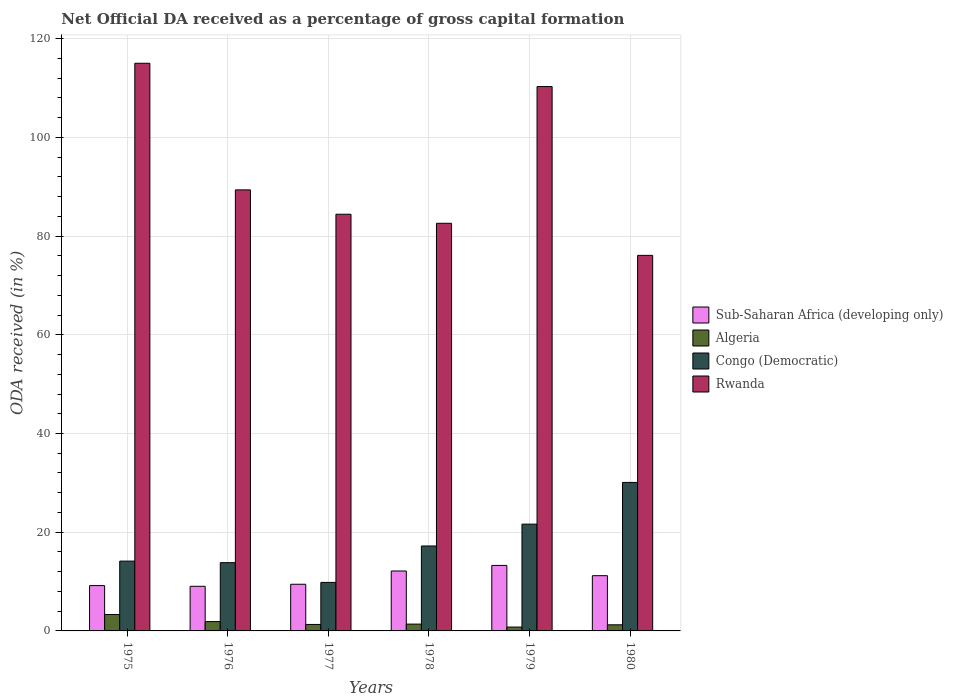How many different coloured bars are there?
Provide a succinct answer. 4. Are the number of bars on each tick of the X-axis equal?
Make the answer very short. Yes. How many bars are there on the 2nd tick from the left?
Provide a short and direct response. 4. What is the label of the 1st group of bars from the left?
Your answer should be very brief. 1975. What is the net ODA received in Rwanda in 1977?
Your answer should be compact. 84.43. Across all years, what is the maximum net ODA received in Congo (Democratic)?
Keep it short and to the point. 30.09. Across all years, what is the minimum net ODA received in Sub-Saharan Africa (developing only)?
Your response must be concise. 9.04. In which year was the net ODA received in Algeria maximum?
Your answer should be compact. 1975. What is the total net ODA received in Algeria in the graph?
Give a very brief answer. 9.94. What is the difference between the net ODA received in Rwanda in 1975 and that in 1978?
Give a very brief answer. 32.42. What is the difference between the net ODA received in Sub-Saharan Africa (developing only) in 1975 and the net ODA received in Algeria in 1979?
Make the answer very short. 8.4. What is the average net ODA received in Algeria per year?
Provide a succinct answer. 1.66. In the year 1980, what is the difference between the net ODA received in Algeria and net ODA received in Congo (Democratic)?
Make the answer very short. -28.85. What is the ratio of the net ODA received in Congo (Democratic) in 1975 to that in 1976?
Give a very brief answer. 1.02. Is the net ODA received in Sub-Saharan Africa (developing only) in 1976 less than that in 1979?
Your answer should be very brief. Yes. What is the difference between the highest and the second highest net ODA received in Algeria?
Offer a terse response. 1.44. What is the difference between the highest and the lowest net ODA received in Algeria?
Provide a succinct answer. 2.55. Is it the case that in every year, the sum of the net ODA received in Sub-Saharan Africa (developing only) and net ODA received in Rwanda is greater than the sum of net ODA received in Congo (Democratic) and net ODA received in Algeria?
Ensure brevity in your answer.  Yes. What does the 2nd bar from the left in 1977 represents?
Your response must be concise. Algeria. What does the 4th bar from the right in 1977 represents?
Your response must be concise. Sub-Saharan Africa (developing only). Is it the case that in every year, the sum of the net ODA received in Algeria and net ODA received in Rwanda is greater than the net ODA received in Congo (Democratic)?
Make the answer very short. Yes. How are the legend labels stacked?
Provide a short and direct response. Vertical. What is the title of the graph?
Offer a very short reply. Net Official DA received as a percentage of gross capital formation. What is the label or title of the X-axis?
Provide a short and direct response. Years. What is the label or title of the Y-axis?
Provide a short and direct response. ODA received (in %). What is the ODA received (in %) in Sub-Saharan Africa (developing only) in 1975?
Your answer should be compact. 9.18. What is the ODA received (in %) in Algeria in 1975?
Offer a terse response. 3.33. What is the ODA received (in %) of Congo (Democratic) in 1975?
Provide a succinct answer. 14.15. What is the ODA received (in %) in Rwanda in 1975?
Give a very brief answer. 115.02. What is the ODA received (in %) in Sub-Saharan Africa (developing only) in 1976?
Provide a short and direct response. 9.04. What is the ODA received (in %) in Algeria in 1976?
Make the answer very short. 1.89. What is the ODA received (in %) of Congo (Democratic) in 1976?
Provide a succinct answer. 13.83. What is the ODA received (in %) of Rwanda in 1976?
Make the answer very short. 89.36. What is the ODA received (in %) in Sub-Saharan Africa (developing only) in 1977?
Make the answer very short. 9.45. What is the ODA received (in %) in Algeria in 1977?
Give a very brief answer. 1.31. What is the ODA received (in %) in Congo (Democratic) in 1977?
Give a very brief answer. 9.83. What is the ODA received (in %) in Rwanda in 1977?
Your response must be concise. 84.43. What is the ODA received (in %) in Sub-Saharan Africa (developing only) in 1978?
Offer a very short reply. 12.14. What is the ODA received (in %) of Algeria in 1978?
Your answer should be compact. 1.38. What is the ODA received (in %) of Congo (Democratic) in 1978?
Provide a short and direct response. 17.21. What is the ODA received (in %) of Rwanda in 1978?
Your answer should be very brief. 82.6. What is the ODA received (in %) of Sub-Saharan Africa (developing only) in 1979?
Provide a short and direct response. 13.27. What is the ODA received (in %) in Algeria in 1979?
Ensure brevity in your answer.  0.78. What is the ODA received (in %) in Congo (Democratic) in 1979?
Offer a terse response. 21.64. What is the ODA received (in %) in Rwanda in 1979?
Offer a terse response. 110.3. What is the ODA received (in %) in Sub-Saharan Africa (developing only) in 1980?
Keep it short and to the point. 11.19. What is the ODA received (in %) of Algeria in 1980?
Give a very brief answer. 1.24. What is the ODA received (in %) in Congo (Democratic) in 1980?
Your response must be concise. 30.09. What is the ODA received (in %) of Rwanda in 1980?
Your answer should be compact. 76.09. Across all years, what is the maximum ODA received (in %) of Sub-Saharan Africa (developing only)?
Give a very brief answer. 13.27. Across all years, what is the maximum ODA received (in %) in Algeria?
Ensure brevity in your answer.  3.33. Across all years, what is the maximum ODA received (in %) of Congo (Democratic)?
Your answer should be very brief. 30.09. Across all years, what is the maximum ODA received (in %) of Rwanda?
Ensure brevity in your answer.  115.02. Across all years, what is the minimum ODA received (in %) in Sub-Saharan Africa (developing only)?
Keep it short and to the point. 9.04. Across all years, what is the minimum ODA received (in %) of Algeria?
Your answer should be very brief. 0.78. Across all years, what is the minimum ODA received (in %) of Congo (Democratic)?
Ensure brevity in your answer.  9.83. Across all years, what is the minimum ODA received (in %) in Rwanda?
Provide a succinct answer. 76.09. What is the total ODA received (in %) of Sub-Saharan Africa (developing only) in the graph?
Provide a short and direct response. 64.29. What is the total ODA received (in %) of Algeria in the graph?
Offer a very short reply. 9.94. What is the total ODA received (in %) of Congo (Democratic) in the graph?
Ensure brevity in your answer.  106.74. What is the total ODA received (in %) in Rwanda in the graph?
Keep it short and to the point. 557.81. What is the difference between the ODA received (in %) of Sub-Saharan Africa (developing only) in 1975 and that in 1976?
Provide a short and direct response. 0.14. What is the difference between the ODA received (in %) of Algeria in 1975 and that in 1976?
Keep it short and to the point. 1.44. What is the difference between the ODA received (in %) in Congo (Democratic) in 1975 and that in 1976?
Ensure brevity in your answer.  0.31. What is the difference between the ODA received (in %) of Rwanda in 1975 and that in 1976?
Offer a terse response. 25.66. What is the difference between the ODA received (in %) of Sub-Saharan Africa (developing only) in 1975 and that in 1977?
Your answer should be compact. -0.27. What is the difference between the ODA received (in %) of Algeria in 1975 and that in 1977?
Make the answer very short. 2.02. What is the difference between the ODA received (in %) in Congo (Democratic) in 1975 and that in 1977?
Make the answer very short. 4.32. What is the difference between the ODA received (in %) in Rwanda in 1975 and that in 1977?
Provide a succinct answer. 30.59. What is the difference between the ODA received (in %) in Sub-Saharan Africa (developing only) in 1975 and that in 1978?
Keep it short and to the point. -2.96. What is the difference between the ODA received (in %) in Algeria in 1975 and that in 1978?
Give a very brief answer. 1.95. What is the difference between the ODA received (in %) in Congo (Democratic) in 1975 and that in 1978?
Offer a very short reply. -3.06. What is the difference between the ODA received (in %) in Rwanda in 1975 and that in 1978?
Ensure brevity in your answer.  32.42. What is the difference between the ODA received (in %) in Sub-Saharan Africa (developing only) in 1975 and that in 1979?
Keep it short and to the point. -4.09. What is the difference between the ODA received (in %) of Algeria in 1975 and that in 1979?
Give a very brief answer. 2.55. What is the difference between the ODA received (in %) of Congo (Democratic) in 1975 and that in 1979?
Ensure brevity in your answer.  -7.49. What is the difference between the ODA received (in %) in Rwanda in 1975 and that in 1979?
Provide a short and direct response. 4.72. What is the difference between the ODA received (in %) of Sub-Saharan Africa (developing only) in 1975 and that in 1980?
Offer a terse response. -2.01. What is the difference between the ODA received (in %) in Algeria in 1975 and that in 1980?
Offer a terse response. 2.09. What is the difference between the ODA received (in %) in Congo (Democratic) in 1975 and that in 1980?
Offer a terse response. -15.94. What is the difference between the ODA received (in %) in Rwanda in 1975 and that in 1980?
Offer a very short reply. 38.93. What is the difference between the ODA received (in %) in Sub-Saharan Africa (developing only) in 1976 and that in 1977?
Your answer should be very brief. -0.41. What is the difference between the ODA received (in %) in Algeria in 1976 and that in 1977?
Give a very brief answer. 0.58. What is the difference between the ODA received (in %) of Congo (Democratic) in 1976 and that in 1977?
Offer a terse response. 4. What is the difference between the ODA received (in %) in Rwanda in 1976 and that in 1977?
Keep it short and to the point. 4.93. What is the difference between the ODA received (in %) of Sub-Saharan Africa (developing only) in 1976 and that in 1978?
Your answer should be compact. -3.1. What is the difference between the ODA received (in %) in Algeria in 1976 and that in 1978?
Your answer should be compact. 0.51. What is the difference between the ODA received (in %) of Congo (Democratic) in 1976 and that in 1978?
Offer a terse response. -3.38. What is the difference between the ODA received (in %) in Rwanda in 1976 and that in 1978?
Provide a succinct answer. 6.76. What is the difference between the ODA received (in %) of Sub-Saharan Africa (developing only) in 1976 and that in 1979?
Offer a very short reply. -4.23. What is the difference between the ODA received (in %) of Algeria in 1976 and that in 1979?
Give a very brief answer. 1.11. What is the difference between the ODA received (in %) in Congo (Democratic) in 1976 and that in 1979?
Your answer should be very brief. -7.81. What is the difference between the ODA received (in %) of Rwanda in 1976 and that in 1979?
Provide a succinct answer. -20.94. What is the difference between the ODA received (in %) of Sub-Saharan Africa (developing only) in 1976 and that in 1980?
Ensure brevity in your answer.  -2.15. What is the difference between the ODA received (in %) of Algeria in 1976 and that in 1980?
Ensure brevity in your answer.  0.65. What is the difference between the ODA received (in %) in Congo (Democratic) in 1976 and that in 1980?
Your response must be concise. -16.26. What is the difference between the ODA received (in %) in Rwanda in 1976 and that in 1980?
Make the answer very short. 13.27. What is the difference between the ODA received (in %) in Sub-Saharan Africa (developing only) in 1977 and that in 1978?
Offer a terse response. -2.69. What is the difference between the ODA received (in %) in Algeria in 1977 and that in 1978?
Provide a succinct answer. -0.07. What is the difference between the ODA received (in %) in Congo (Democratic) in 1977 and that in 1978?
Offer a very short reply. -7.38. What is the difference between the ODA received (in %) of Rwanda in 1977 and that in 1978?
Keep it short and to the point. 1.83. What is the difference between the ODA received (in %) of Sub-Saharan Africa (developing only) in 1977 and that in 1979?
Offer a terse response. -3.82. What is the difference between the ODA received (in %) in Algeria in 1977 and that in 1979?
Keep it short and to the point. 0.53. What is the difference between the ODA received (in %) of Congo (Democratic) in 1977 and that in 1979?
Offer a very short reply. -11.81. What is the difference between the ODA received (in %) of Rwanda in 1977 and that in 1979?
Offer a very short reply. -25.87. What is the difference between the ODA received (in %) in Sub-Saharan Africa (developing only) in 1977 and that in 1980?
Provide a succinct answer. -1.74. What is the difference between the ODA received (in %) of Algeria in 1977 and that in 1980?
Your response must be concise. 0.07. What is the difference between the ODA received (in %) in Congo (Democratic) in 1977 and that in 1980?
Provide a succinct answer. -20.26. What is the difference between the ODA received (in %) of Rwanda in 1977 and that in 1980?
Your answer should be very brief. 8.34. What is the difference between the ODA received (in %) in Sub-Saharan Africa (developing only) in 1978 and that in 1979?
Your answer should be compact. -1.13. What is the difference between the ODA received (in %) in Algeria in 1978 and that in 1979?
Provide a succinct answer. 0.6. What is the difference between the ODA received (in %) in Congo (Democratic) in 1978 and that in 1979?
Your response must be concise. -4.43. What is the difference between the ODA received (in %) of Rwanda in 1978 and that in 1979?
Your response must be concise. -27.7. What is the difference between the ODA received (in %) in Sub-Saharan Africa (developing only) in 1978 and that in 1980?
Offer a very short reply. 0.95. What is the difference between the ODA received (in %) in Algeria in 1978 and that in 1980?
Ensure brevity in your answer.  0.14. What is the difference between the ODA received (in %) of Congo (Democratic) in 1978 and that in 1980?
Offer a very short reply. -12.88. What is the difference between the ODA received (in %) in Rwanda in 1978 and that in 1980?
Your response must be concise. 6.51. What is the difference between the ODA received (in %) of Sub-Saharan Africa (developing only) in 1979 and that in 1980?
Keep it short and to the point. 2.08. What is the difference between the ODA received (in %) in Algeria in 1979 and that in 1980?
Give a very brief answer. -0.46. What is the difference between the ODA received (in %) in Congo (Democratic) in 1979 and that in 1980?
Ensure brevity in your answer.  -8.45. What is the difference between the ODA received (in %) of Rwanda in 1979 and that in 1980?
Your answer should be compact. 34.21. What is the difference between the ODA received (in %) of Sub-Saharan Africa (developing only) in 1975 and the ODA received (in %) of Algeria in 1976?
Provide a short and direct response. 7.29. What is the difference between the ODA received (in %) of Sub-Saharan Africa (developing only) in 1975 and the ODA received (in %) of Congo (Democratic) in 1976?
Your response must be concise. -4.65. What is the difference between the ODA received (in %) of Sub-Saharan Africa (developing only) in 1975 and the ODA received (in %) of Rwanda in 1976?
Provide a succinct answer. -80.18. What is the difference between the ODA received (in %) in Algeria in 1975 and the ODA received (in %) in Congo (Democratic) in 1976?
Give a very brief answer. -10.5. What is the difference between the ODA received (in %) of Algeria in 1975 and the ODA received (in %) of Rwanda in 1976?
Give a very brief answer. -86.03. What is the difference between the ODA received (in %) of Congo (Democratic) in 1975 and the ODA received (in %) of Rwanda in 1976?
Ensure brevity in your answer.  -75.22. What is the difference between the ODA received (in %) in Sub-Saharan Africa (developing only) in 1975 and the ODA received (in %) in Algeria in 1977?
Offer a terse response. 7.87. What is the difference between the ODA received (in %) of Sub-Saharan Africa (developing only) in 1975 and the ODA received (in %) of Congo (Democratic) in 1977?
Your answer should be very brief. -0.65. What is the difference between the ODA received (in %) of Sub-Saharan Africa (developing only) in 1975 and the ODA received (in %) of Rwanda in 1977?
Give a very brief answer. -75.25. What is the difference between the ODA received (in %) in Algeria in 1975 and the ODA received (in %) in Congo (Democratic) in 1977?
Your answer should be very brief. -6.5. What is the difference between the ODA received (in %) in Algeria in 1975 and the ODA received (in %) in Rwanda in 1977?
Give a very brief answer. -81.1. What is the difference between the ODA received (in %) in Congo (Democratic) in 1975 and the ODA received (in %) in Rwanda in 1977?
Provide a short and direct response. -70.28. What is the difference between the ODA received (in %) in Sub-Saharan Africa (developing only) in 1975 and the ODA received (in %) in Algeria in 1978?
Offer a terse response. 7.8. What is the difference between the ODA received (in %) of Sub-Saharan Africa (developing only) in 1975 and the ODA received (in %) of Congo (Democratic) in 1978?
Make the answer very short. -8.03. What is the difference between the ODA received (in %) of Sub-Saharan Africa (developing only) in 1975 and the ODA received (in %) of Rwanda in 1978?
Give a very brief answer. -73.42. What is the difference between the ODA received (in %) in Algeria in 1975 and the ODA received (in %) in Congo (Democratic) in 1978?
Your response must be concise. -13.88. What is the difference between the ODA received (in %) of Algeria in 1975 and the ODA received (in %) of Rwanda in 1978?
Give a very brief answer. -79.27. What is the difference between the ODA received (in %) in Congo (Democratic) in 1975 and the ODA received (in %) in Rwanda in 1978?
Your response must be concise. -68.45. What is the difference between the ODA received (in %) of Sub-Saharan Africa (developing only) in 1975 and the ODA received (in %) of Algeria in 1979?
Your answer should be very brief. 8.4. What is the difference between the ODA received (in %) in Sub-Saharan Africa (developing only) in 1975 and the ODA received (in %) in Congo (Democratic) in 1979?
Your response must be concise. -12.45. What is the difference between the ODA received (in %) of Sub-Saharan Africa (developing only) in 1975 and the ODA received (in %) of Rwanda in 1979?
Give a very brief answer. -101.12. What is the difference between the ODA received (in %) in Algeria in 1975 and the ODA received (in %) in Congo (Democratic) in 1979?
Keep it short and to the point. -18.31. What is the difference between the ODA received (in %) of Algeria in 1975 and the ODA received (in %) of Rwanda in 1979?
Your response must be concise. -106.97. What is the difference between the ODA received (in %) of Congo (Democratic) in 1975 and the ODA received (in %) of Rwanda in 1979?
Provide a short and direct response. -96.15. What is the difference between the ODA received (in %) in Sub-Saharan Africa (developing only) in 1975 and the ODA received (in %) in Algeria in 1980?
Offer a very short reply. 7.94. What is the difference between the ODA received (in %) of Sub-Saharan Africa (developing only) in 1975 and the ODA received (in %) of Congo (Democratic) in 1980?
Your response must be concise. -20.9. What is the difference between the ODA received (in %) of Sub-Saharan Africa (developing only) in 1975 and the ODA received (in %) of Rwanda in 1980?
Offer a terse response. -66.91. What is the difference between the ODA received (in %) of Algeria in 1975 and the ODA received (in %) of Congo (Democratic) in 1980?
Offer a terse response. -26.76. What is the difference between the ODA received (in %) of Algeria in 1975 and the ODA received (in %) of Rwanda in 1980?
Make the answer very short. -72.76. What is the difference between the ODA received (in %) of Congo (Democratic) in 1975 and the ODA received (in %) of Rwanda in 1980?
Provide a short and direct response. -61.95. What is the difference between the ODA received (in %) of Sub-Saharan Africa (developing only) in 1976 and the ODA received (in %) of Algeria in 1977?
Provide a short and direct response. 7.73. What is the difference between the ODA received (in %) in Sub-Saharan Africa (developing only) in 1976 and the ODA received (in %) in Congo (Democratic) in 1977?
Make the answer very short. -0.79. What is the difference between the ODA received (in %) in Sub-Saharan Africa (developing only) in 1976 and the ODA received (in %) in Rwanda in 1977?
Ensure brevity in your answer.  -75.39. What is the difference between the ODA received (in %) in Algeria in 1976 and the ODA received (in %) in Congo (Democratic) in 1977?
Give a very brief answer. -7.94. What is the difference between the ODA received (in %) of Algeria in 1976 and the ODA received (in %) of Rwanda in 1977?
Your response must be concise. -82.54. What is the difference between the ODA received (in %) in Congo (Democratic) in 1976 and the ODA received (in %) in Rwanda in 1977?
Ensure brevity in your answer.  -70.6. What is the difference between the ODA received (in %) of Sub-Saharan Africa (developing only) in 1976 and the ODA received (in %) of Algeria in 1978?
Offer a very short reply. 7.66. What is the difference between the ODA received (in %) in Sub-Saharan Africa (developing only) in 1976 and the ODA received (in %) in Congo (Democratic) in 1978?
Give a very brief answer. -8.17. What is the difference between the ODA received (in %) in Sub-Saharan Africa (developing only) in 1976 and the ODA received (in %) in Rwanda in 1978?
Offer a terse response. -73.56. What is the difference between the ODA received (in %) in Algeria in 1976 and the ODA received (in %) in Congo (Democratic) in 1978?
Your answer should be compact. -15.32. What is the difference between the ODA received (in %) in Algeria in 1976 and the ODA received (in %) in Rwanda in 1978?
Your response must be concise. -80.71. What is the difference between the ODA received (in %) of Congo (Democratic) in 1976 and the ODA received (in %) of Rwanda in 1978?
Offer a very short reply. -68.77. What is the difference between the ODA received (in %) in Sub-Saharan Africa (developing only) in 1976 and the ODA received (in %) in Algeria in 1979?
Your answer should be very brief. 8.26. What is the difference between the ODA received (in %) of Sub-Saharan Africa (developing only) in 1976 and the ODA received (in %) of Congo (Democratic) in 1979?
Offer a very short reply. -12.59. What is the difference between the ODA received (in %) in Sub-Saharan Africa (developing only) in 1976 and the ODA received (in %) in Rwanda in 1979?
Offer a very short reply. -101.26. What is the difference between the ODA received (in %) of Algeria in 1976 and the ODA received (in %) of Congo (Democratic) in 1979?
Your answer should be very brief. -19.75. What is the difference between the ODA received (in %) in Algeria in 1976 and the ODA received (in %) in Rwanda in 1979?
Give a very brief answer. -108.41. What is the difference between the ODA received (in %) in Congo (Democratic) in 1976 and the ODA received (in %) in Rwanda in 1979?
Make the answer very short. -96.47. What is the difference between the ODA received (in %) of Sub-Saharan Africa (developing only) in 1976 and the ODA received (in %) of Algeria in 1980?
Your response must be concise. 7.8. What is the difference between the ODA received (in %) in Sub-Saharan Africa (developing only) in 1976 and the ODA received (in %) in Congo (Democratic) in 1980?
Keep it short and to the point. -21.04. What is the difference between the ODA received (in %) in Sub-Saharan Africa (developing only) in 1976 and the ODA received (in %) in Rwanda in 1980?
Provide a succinct answer. -67.05. What is the difference between the ODA received (in %) of Algeria in 1976 and the ODA received (in %) of Congo (Democratic) in 1980?
Your answer should be compact. -28.2. What is the difference between the ODA received (in %) in Algeria in 1976 and the ODA received (in %) in Rwanda in 1980?
Your answer should be compact. -74.2. What is the difference between the ODA received (in %) in Congo (Democratic) in 1976 and the ODA received (in %) in Rwanda in 1980?
Give a very brief answer. -62.26. What is the difference between the ODA received (in %) in Sub-Saharan Africa (developing only) in 1977 and the ODA received (in %) in Algeria in 1978?
Give a very brief answer. 8.07. What is the difference between the ODA received (in %) of Sub-Saharan Africa (developing only) in 1977 and the ODA received (in %) of Congo (Democratic) in 1978?
Ensure brevity in your answer.  -7.76. What is the difference between the ODA received (in %) of Sub-Saharan Africa (developing only) in 1977 and the ODA received (in %) of Rwanda in 1978?
Offer a very short reply. -73.15. What is the difference between the ODA received (in %) of Algeria in 1977 and the ODA received (in %) of Congo (Democratic) in 1978?
Make the answer very short. -15.9. What is the difference between the ODA received (in %) of Algeria in 1977 and the ODA received (in %) of Rwanda in 1978?
Your response must be concise. -81.29. What is the difference between the ODA received (in %) in Congo (Democratic) in 1977 and the ODA received (in %) in Rwanda in 1978?
Your answer should be compact. -72.77. What is the difference between the ODA received (in %) of Sub-Saharan Africa (developing only) in 1977 and the ODA received (in %) of Algeria in 1979?
Ensure brevity in your answer.  8.67. What is the difference between the ODA received (in %) in Sub-Saharan Africa (developing only) in 1977 and the ODA received (in %) in Congo (Democratic) in 1979?
Provide a succinct answer. -12.18. What is the difference between the ODA received (in %) in Sub-Saharan Africa (developing only) in 1977 and the ODA received (in %) in Rwanda in 1979?
Your answer should be very brief. -100.85. What is the difference between the ODA received (in %) of Algeria in 1977 and the ODA received (in %) of Congo (Democratic) in 1979?
Your answer should be very brief. -20.32. What is the difference between the ODA received (in %) in Algeria in 1977 and the ODA received (in %) in Rwanda in 1979?
Offer a very short reply. -108.99. What is the difference between the ODA received (in %) of Congo (Democratic) in 1977 and the ODA received (in %) of Rwanda in 1979?
Offer a terse response. -100.47. What is the difference between the ODA received (in %) in Sub-Saharan Africa (developing only) in 1977 and the ODA received (in %) in Algeria in 1980?
Offer a very short reply. 8.21. What is the difference between the ODA received (in %) in Sub-Saharan Africa (developing only) in 1977 and the ODA received (in %) in Congo (Democratic) in 1980?
Give a very brief answer. -20.63. What is the difference between the ODA received (in %) of Sub-Saharan Africa (developing only) in 1977 and the ODA received (in %) of Rwanda in 1980?
Provide a short and direct response. -66.64. What is the difference between the ODA received (in %) of Algeria in 1977 and the ODA received (in %) of Congo (Democratic) in 1980?
Your response must be concise. -28.78. What is the difference between the ODA received (in %) of Algeria in 1977 and the ODA received (in %) of Rwanda in 1980?
Offer a very short reply. -74.78. What is the difference between the ODA received (in %) in Congo (Democratic) in 1977 and the ODA received (in %) in Rwanda in 1980?
Offer a terse response. -66.26. What is the difference between the ODA received (in %) in Sub-Saharan Africa (developing only) in 1978 and the ODA received (in %) in Algeria in 1979?
Your response must be concise. 11.36. What is the difference between the ODA received (in %) of Sub-Saharan Africa (developing only) in 1978 and the ODA received (in %) of Congo (Democratic) in 1979?
Your answer should be compact. -9.49. What is the difference between the ODA received (in %) of Sub-Saharan Africa (developing only) in 1978 and the ODA received (in %) of Rwanda in 1979?
Give a very brief answer. -98.16. What is the difference between the ODA received (in %) in Algeria in 1978 and the ODA received (in %) in Congo (Democratic) in 1979?
Make the answer very short. -20.25. What is the difference between the ODA received (in %) in Algeria in 1978 and the ODA received (in %) in Rwanda in 1979?
Your answer should be very brief. -108.92. What is the difference between the ODA received (in %) in Congo (Democratic) in 1978 and the ODA received (in %) in Rwanda in 1979?
Your response must be concise. -93.09. What is the difference between the ODA received (in %) in Sub-Saharan Africa (developing only) in 1978 and the ODA received (in %) in Algeria in 1980?
Provide a short and direct response. 10.9. What is the difference between the ODA received (in %) in Sub-Saharan Africa (developing only) in 1978 and the ODA received (in %) in Congo (Democratic) in 1980?
Provide a short and direct response. -17.95. What is the difference between the ODA received (in %) in Sub-Saharan Africa (developing only) in 1978 and the ODA received (in %) in Rwanda in 1980?
Your answer should be compact. -63.95. What is the difference between the ODA received (in %) of Algeria in 1978 and the ODA received (in %) of Congo (Democratic) in 1980?
Give a very brief answer. -28.71. What is the difference between the ODA received (in %) in Algeria in 1978 and the ODA received (in %) in Rwanda in 1980?
Your answer should be compact. -74.71. What is the difference between the ODA received (in %) in Congo (Democratic) in 1978 and the ODA received (in %) in Rwanda in 1980?
Your answer should be compact. -58.88. What is the difference between the ODA received (in %) of Sub-Saharan Africa (developing only) in 1979 and the ODA received (in %) of Algeria in 1980?
Provide a short and direct response. 12.03. What is the difference between the ODA received (in %) of Sub-Saharan Africa (developing only) in 1979 and the ODA received (in %) of Congo (Democratic) in 1980?
Provide a short and direct response. -16.82. What is the difference between the ODA received (in %) in Sub-Saharan Africa (developing only) in 1979 and the ODA received (in %) in Rwanda in 1980?
Offer a very short reply. -62.82. What is the difference between the ODA received (in %) of Algeria in 1979 and the ODA received (in %) of Congo (Democratic) in 1980?
Offer a terse response. -29.3. What is the difference between the ODA received (in %) of Algeria in 1979 and the ODA received (in %) of Rwanda in 1980?
Offer a terse response. -75.31. What is the difference between the ODA received (in %) in Congo (Democratic) in 1979 and the ODA received (in %) in Rwanda in 1980?
Provide a succinct answer. -54.46. What is the average ODA received (in %) in Sub-Saharan Africa (developing only) per year?
Make the answer very short. 10.71. What is the average ODA received (in %) of Algeria per year?
Provide a succinct answer. 1.66. What is the average ODA received (in %) of Congo (Democratic) per year?
Your response must be concise. 17.79. What is the average ODA received (in %) of Rwanda per year?
Offer a very short reply. 92.97. In the year 1975, what is the difference between the ODA received (in %) of Sub-Saharan Africa (developing only) and ODA received (in %) of Algeria?
Provide a short and direct response. 5.85. In the year 1975, what is the difference between the ODA received (in %) of Sub-Saharan Africa (developing only) and ODA received (in %) of Congo (Democratic)?
Provide a succinct answer. -4.96. In the year 1975, what is the difference between the ODA received (in %) in Sub-Saharan Africa (developing only) and ODA received (in %) in Rwanda?
Your answer should be very brief. -105.84. In the year 1975, what is the difference between the ODA received (in %) of Algeria and ODA received (in %) of Congo (Democratic)?
Your response must be concise. -10.82. In the year 1975, what is the difference between the ODA received (in %) in Algeria and ODA received (in %) in Rwanda?
Provide a succinct answer. -111.69. In the year 1975, what is the difference between the ODA received (in %) of Congo (Democratic) and ODA received (in %) of Rwanda?
Give a very brief answer. -100.88. In the year 1976, what is the difference between the ODA received (in %) in Sub-Saharan Africa (developing only) and ODA received (in %) in Algeria?
Provide a short and direct response. 7.15. In the year 1976, what is the difference between the ODA received (in %) of Sub-Saharan Africa (developing only) and ODA received (in %) of Congo (Democratic)?
Your response must be concise. -4.79. In the year 1976, what is the difference between the ODA received (in %) in Sub-Saharan Africa (developing only) and ODA received (in %) in Rwanda?
Make the answer very short. -80.32. In the year 1976, what is the difference between the ODA received (in %) in Algeria and ODA received (in %) in Congo (Democratic)?
Provide a succinct answer. -11.94. In the year 1976, what is the difference between the ODA received (in %) of Algeria and ODA received (in %) of Rwanda?
Keep it short and to the point. -87.47. In the year 1976, what is the difference between the ODA received (in %) of Congo (Democratic) and ODA received (in %) of Rwanda?
Make the answer very short. -75.53. In the year 1977, what is the difference between the ODA received (in %) of Sub-Saharan Africa (developing only) and ODA received (in %) of Algeria?
Your response must be concise. 8.14. In the year 1977, what is the difference between the ODA received (in %) in Sub-Saharan Africa (developing only) and ODA received (in %) in Congo (Democratic)?
Keep it short and to the point. -0.38. In the year 1977, what is the difference between the ODA received (in %) of Sub-Saharan Africa (developing only) and ODA received (in %) of Rwanda?
Ensure brevity in your answer.  -74.98. In the year 1977, what is the difference between the ODA received (in %) in Algeria and ODA received (in %) in Congo (Democratic)?
Provide a short and direct response. -8.52. In the year 1977, what is the difference between the ODA received (in %) in Algeria and ODA received (in %) in Rwanda?
Offer a terse response. -83.12. In the year 1977, what is the difference between the ODA received (in %) of Congo (Democratic) and ODA received (in %) of Rwanda?
Provide a short and direct response. -74.6. In the year 1978, what is the difference between the ODA received (in %) in Sub-Saharan Africa (developing only) and ODA received (in %) in Algeria?
Offer a very short reply. 10.76. In the year 1978, what is the difference between the ODA received (in %) of Sub-Saharan Africa (developing only) and ODA received (in %) of Congo (Democratic)?
Ensure brevity in your answer.  -5.07. In the year 1978, what is the difference between the ODA received (in %) of Sub-Saharan Africa (developing only) and ODA received (in %) of Rwanda?
Offer a terse response. -70.46. In the year 1978, what is the difference between the ODA received (in %) in Algeria and ODA received (in %) in Congo (Democratic)?
Ensure brevity in your answer.  -15.83. In the year 1978, what is the difference between the ODA received (in %) of Algeria and ODA received (in %) of Rwanda?
Make the answer very short. -81.22. In the year 1978, what is the difference between the ODA received (in %) of Congo (Democratic) and ODA received (in %) of Rwanda?
Ensure brevity in your answer.  -65.39. In the year 1979, what is the difference between the ODA received (in %) of Sub-Saharan Africa (developing only) and ODA received (in %) of Algeria?
Make the answer very short. 12.49. In the year 1979, what is the difference between the ODA received (in %) in Sub-Saharan Africa (developing only) and ODA received (in %) in Congo (Democratic)?
Your answer should be very brief. -8.37. In the year 1979, what is the difference between the ODA received (in %) of Sub-Saharan Africa (developing only) and ODA received (in %) of Rwanda?
Offer a very short reply. -97.03. In the year 1979, what is the difference between the ODA received (in %) of Algeria and ODA received (in %) of Congo (Democratic)?
Ensure brevity in your answer.  -20.85. In the year 1979, what is the difference between the ODA received (in %) of Algeria and ODA received (in %) of Rwanda?
Your response must be concise. -109.52. In the year 1979, what is the difference between the ODA received (in %) of Congo (Democratic) and ODA received (in %) of Rwanda?
Provide a succinct answer. -88.66. In the year 1980, what is the difference between the ODA received (in %) in Sub-Saharan Africa (developing only) and ODA received (in %) in Algeria?
Provide a succinct answer. 9.95. In the year 1980, what is the difference between the ODA received (in %) of Sub-Saharan Africa (developing only) and ODA received (in %) of Congo (Democratic)?
Your answer should be compact. -18.89. In the year 1980, what is the difference between the ODA received (in %) of Sub-Saharan Africa (developing only) and ODA received (in %) of Rwanda?
Provide a short and direct response. -64.9. In the year 1980, what is the difference between the ODA received (in %) of Algeria and ODA received (in %) of Congo (Democratic)?
Provide a succinct answer. -28.85. In the year 1980, what is the difference between the ODA received (in %) in Algeria and ODA received (in %) in Rwanda?
Keep it short and to the point. -74.85. In the year 1980, what is the difference between the ODA received (in %) of Congo (Democratic) and ODA received (in %) of Rwanda?
Make the answer very short. -46.01. What is the ratio of the ODA received (in %) in Sub-Saharan Africa (developing only) in 1975 to that in 1976?
Your answer should be compact. 1.02. What is the ratio of the ODA received (in %) of Algeria in 1975 to that in 1976?
Ensure brevity in your answer.  1.76. What is the ratio of the ODA received (in %) in Congo (Democratic) in 1975 to that in 1976?
Offer a terse response. 1.02. What is the ratio of the ODA received (in %) in Rwanda in 1975 to that in 1976?
Your answer should be very brief. 1.29. What is the ratio of the ODA received (in %) of Sub-Saharan Africa (developing only) in 1975 to that in 1977?
Keep it short and to the point. 0.97. What is the ratio of the ODA received (in %) of Algeria in 1975 to that in 1977?
Give a very brief answer. 2.54. What is the ratio of the ODA received (in %) of Congo (Democratic) in 1975 to that in 1977?
Your answer should be very brief. 1.44. What is the ratio of the ODA received (in %) of Rwanda in 1975 to that in 1977?
Make the answer very short. 1.36. What is the ratio of the ODA received (in %) of Sub-Saharan Africa (developing only) in 1975 to that in 1978?
Keep it short and to the point. 0.76. What is the ratio of the ODA received (in %) in Algeria in 1975 to that in 1978?
Give a very brief answer. 2.41. What is the ratio of the ODA received (in %) in Congo (Democratic) in 1975 to that in 1978?
Your answer should be very brief. 0.82. What is the ratio of the ODA received (in %) of Rwanda in 1975 to that in 1978?
Your answer should be compact. 1.39. What is the ratio of the ODA received (in %) of Sub-Saharan Africa (developing only) in 1975 to that in 1979?
Offer a very short reply. 0.69. What is the ratio of the ODA received (in %) of Algeria in 1975 to that in 1979?
Provide a succinct answer. 4.25. What is the ratio of the ODA received (in %) of Congo (Democratic) in 1975 to that in 1979?
Offer a very short reply. 0.65. What is the ratio of the ODA received (in %) in Rwanda in 1975 to that in 1979?
Provide a short and direct response. 1.04. What is the ratio of the ODA received (in %) of Sub-Saharan Africa (developing only) in 1975 to that in 1980?
Your answer should be compact. 0.82. What is the ratio of the ODA received (in %) of Algeria in 1975 to that in 1980?
Your answer should be very brief. 2.69. What is the ratio of the ODA received (in %) of Congo (Democratic) in 1975 to that in 1980?
Your answer should be very brief. 0.47. What is the ratio of the ODA received (in %) of Rwanda in 1975 to that in 1980?
Your response must be concise. 1.51. What is the ratio of the ODA received (in %) of Sub-Saharan Africa (developing only) in 1976 to that in 1977?
Offer a terse response. 0.96. What is the ratio of the ODA received (in %) of Algeria in 1976 to that in 1977?
Provide a short and direct response. 1.44. What is the ratio of the ODA received (in %) in Congo (Democratic) in 1976 to that in 1977?
Provide a succinct answer. 1.41. What is the ratio of the ODA received (in %) in Rwanda in 1976 to that in 1977?
Ensure brevity in your answer.  1.06. What is the ratio of the ODA received (in %) in Sub-Saharan Africa (developing only) in 1976 to that in 1978?
Your answer should be compact. 0.74. What is the ratio of the ODA received (in %) of Algeria in 1976 to that in 1978?
Provide a short and direct response. 1.37. What is the ratio of the ODA received (in %) in Congo (Democratic) in 1976 to that in 1978?
Keep it short and to the point. 0.8. What is the ratio of the ODA received (in %) in Rwanda in 1976 to that in 1978?
Offer a very short reply. 1.08. What is the ratio of the ODA received (in %) in Sub-Saharan Africa (developing only) in 1976 to that in 1979?
Provide a short and direct response. 0.68. What is the ratio of the ODA received (in %) in Algeria in 1976 to that in 1979?
Offer a terse response. 2.41. What is the ratio of the ODA received (in %) in Congo (Democratic) in 1976 to that in 1979?
Keep it short and to the point. 0.64. What is the ratio of the ODA received (in %) in Rwanda in 1976 to that in 1979?
Give a very brief answer. 0.81. What is the ratio of the ODA received (in %) in Sub-Saharan Africa (developing only) in 1976 to that in 1980?
Give a very brief answer. 0.81. What is the ratio of the ODA received (in %) of Algeria in 1976 to that in 1980?
Offer a very short reply. 1.53. What is the ratio of the ODA received (in %) in Congo (Democratic) in 1976 to that in 1980?
Your answer should be very brief. 0.46. What is the ratio of the ODA received (in %) in Rwanda in 1976 to that in 1980?
Your answer should be compact. 1.17. What is the ratio of the ODA received (in %) of Sub-Saharan Africa (developing only) in 1977 to that in 1978?
Your response must be concise. 0.78. What is the ratio of the ODA received (in %) in Algeria in 1977 to that in 1978?
Ensure brevity in your answer.  0.95. What is the ratio of the ODA received (in %) in Congo (Democratic) in 1977 to that in 1978?
Offer a very short reply. 0.57. What is the ratio of the ODA received (in %) of Rwanda in 1977 to that in 1978?
Provide a succinct answer. 1.02. What is the ratio of the ODA received (in %) of Sub-Saharan Africa (developing only) in 1977 to that in 1979?
Provide a short and direct response. 0.71. What is the ratio of the ODA received (in %) of Algeria in 1977 to that in 1979?
Give a very brief answer. 1.68. What is the ratio of the ODA received (in %) in Congo (Democratic) in 1977 to that in 1979?
Your response must be concise. 0.45. What is the ratio of the ODA received (in %) of Rwanda in 1977 to that in 1979?
Your answer should be very brief. 0.77. What is the ratio of the ODA received (in %) in Sub-Saharan Africa (developing only) in 1977 to that in 1980?
Provide a succinct answer. 0.84. What is the ratio of the ODA received (in %) of Algeria in 1977 to that in 1980?
Your answer should be compact. 1.06. What is the ratio of the ODA received (in %) in Congo (Democratic) in 1977 to that in 1980?
Give a very brief answer. 0.33. What is the ratio of the ODA received (in %) in Rwanda in 1977 to that in 1980?
Offer a very short reply. 1.11. What is the ratio of the ODA received (in %) in Sub-Saharan Africa (developing only) in 1978 to that in 1979?
Keep it short and to the point. 0.91. What is the ratio of the ODA received (in %) of Algeria in 1978 to that in 1979?
Keep it short and to the point. 1.76. What is the ratio of the ODA received (in %) in Congo (Democratic) in 1978 to that in 1979?
Provide a short and direct response. 0.8. What is the ratio of the ODA received (in %) in Rwanda in 1978 to that in 1979?
Give a very brief answer. 0.75. What is the ratio of the ODA received (in %) of Sub-Saharan Africa (developing only) in 1978 to that in 1980?
Provide a succinct answer. 1.08. What is the ratio of the ODA received (in %) of Algeria in 1978 to that in 1980?
Ensure brevity in your answer.  1.11. What is the ratio of the ODA received (in %) of Congo (Democratic) in 1978 to that in 1980?
Provide a succinct answer. 0.57. What is the ratio of the ODA received (in %) of Rwanda in 1978 to that in 1980?
Ensure brevity in your answer.  1.09. What is the ratio of the ODA received (in %) of Sub-Saharan Africa (developing only) in 1979 to that in 1980?
Your response must be concise. 1.19. What is the ratio of the ODA received (in %) in Algeria in 1979 to that in 1980?
Your answer should be very brief. 0.63. What is the ratio of the ODA received (in %) in Congo (Democratic) in 1979 to that in 1980?
Keep it short and to the point. 0.72. What is the ratio of the ODA received (in %) in Rwanda in 1979 to that in 1980?
Provide a succinct answer. 1.45. What is the difference between the highest and the second highest ODA received (in %) of Sub-Saharan Africa (developing only)?
Provide a short and direct response. 1.13. What is the difference between the highest and the second highest ODA received (in %) in Algeria?
Your answer should be compact. 1.44. What is the difference between the highest and the second highest ODA received (in %) of Congo (Democratic)?
Provide a short and direct response. 8.45. What is the difference between the highest and the second highest ODA received (in %) of Rwanda?
Give a very brief answer. 4.72. What is the difference between the highest and the lowest ODA received (in %) in Sub-Saharan Africa (developing only)?
Make the answer very short. 4.23. What is the difference between the highest and the lowest ODA received (in %) in Algeria?
Keep it short and to the point. 2.55. What is the difference between the highest and the lowest ODA received (in %) in Congo (Democratic)?
Provide a short and direct response. 20.26. What is the difference between the highest and the lowest ODA received (in %) in Rwanda?
Your answer should be compact. 38.93. 